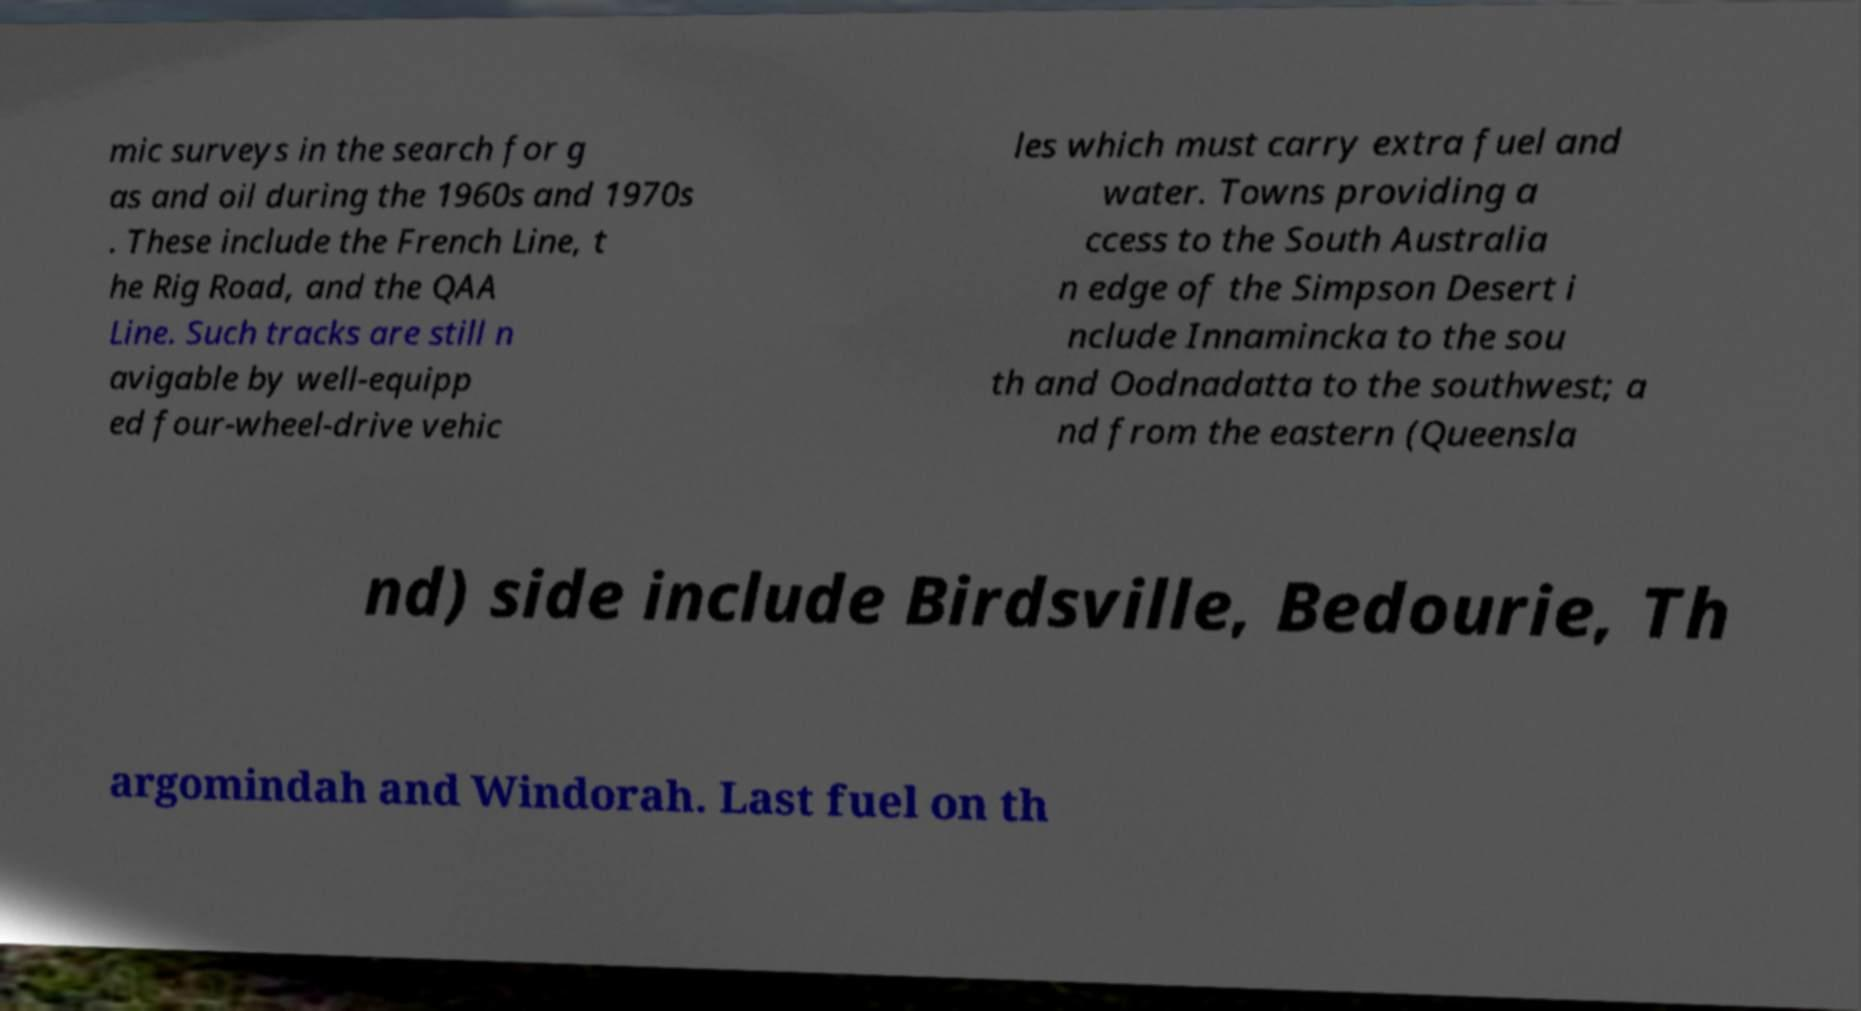There's text embedded in this image that I need extracted. Can you transcribe it verbatim? mic surveys in the search for g as and oil during the 1960s and 1970s . These include the French Line, t he Rig Road, and the QAA Line. Such tracks are still n avigable by well-equipp ed four-wheel-drive vehic les which must carry extra fuel and water. Towns providing a ccess to the South Australia n edge of the Simpson Desert i nclude Innamincka to the sou th and Oodnadatta to the southwest; a nd from the eastern (Queensla nd) side include Birdsville, Bedourie, Th argomindah and Windorah. Last fuel on th 